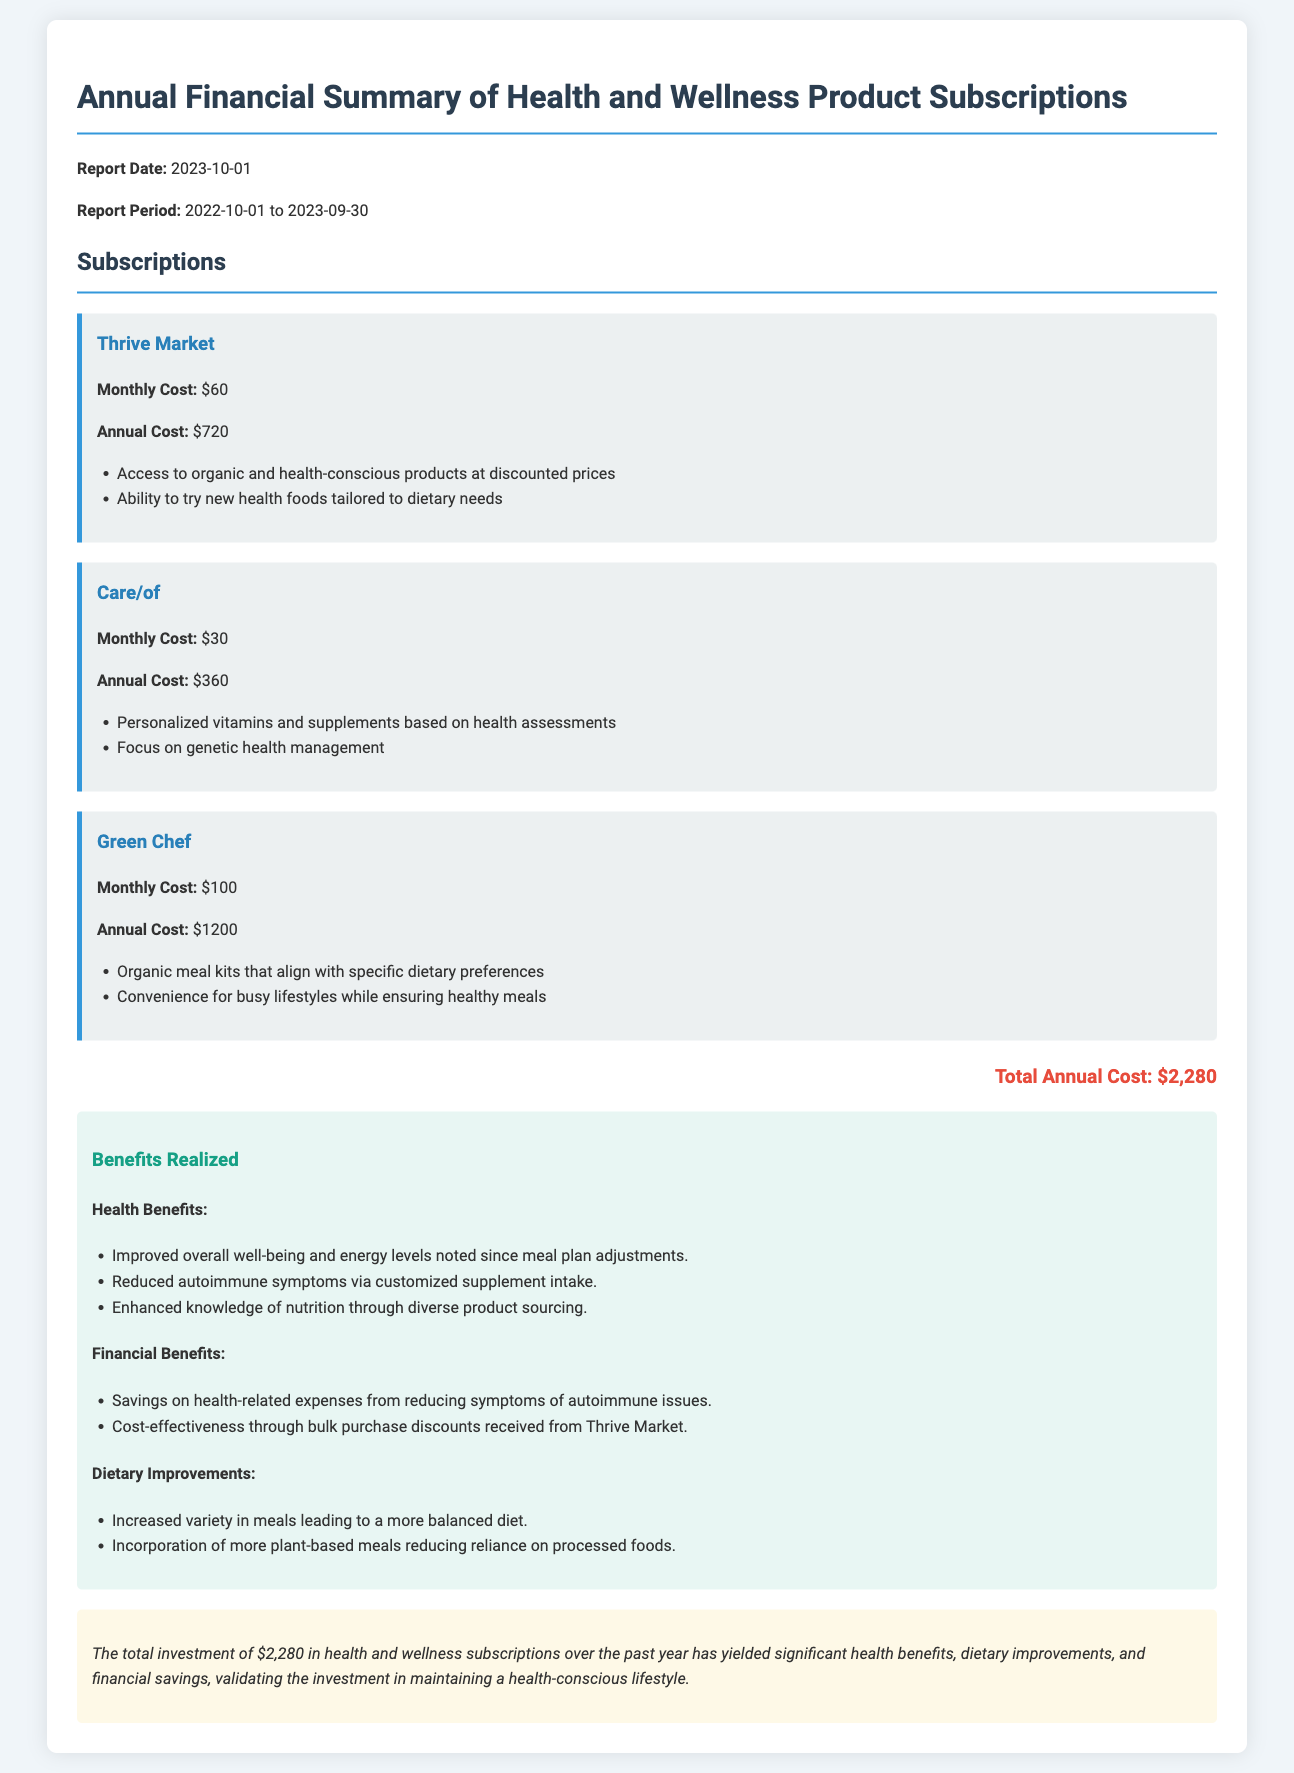What is the report date? The report date is provided at the beginning of the document, which states "Report Date: 2023-10-01".
Answer: 2023-10-01 What is the total annual cost of subscriptions? The document lists the total annual cost at the bottom of the subscriptions section; it states "Total Annual Cost: $2,280".
Answer: $2,280 How much does Green Chef cost monthly? The monthly cost for Green Chef is directly listed in the document as "$100".
Answer: $100 What is one of the financial benefits realized? The document mentions several financial benefits, including "Savings on health-related expenses from reducing symptoms of autoimmune issues".
Answer: Savings on health-related expenses Which subscription focuses on genetic health management? The document clearly specifies that Care/of provides "Personalized vitamins and supplements based on health assessments".
Answer: Care/of What dietary improvements are noted in the benefits? The document notes dietary improvements such as "Increased variety in meals leading to a more balanced diet".
Answer: Increased variety in meals leading to a more balanced diet What is the annual cost of Thrive Market? The document specifies the annual cost of Thrive Market as "$720".
Answer: $720 How many subscriptions are mentioned in the document? The document outlines three subscriptions: Thrive Market, Care/of, and Green Chef.
Answer: Three What is the conclusion about the overall investment? The conclusion states, "The total investment of $2,280 in health and wellness subscriptions over the past year has yielded significant health benefits."
Answer: Significant health benefits 